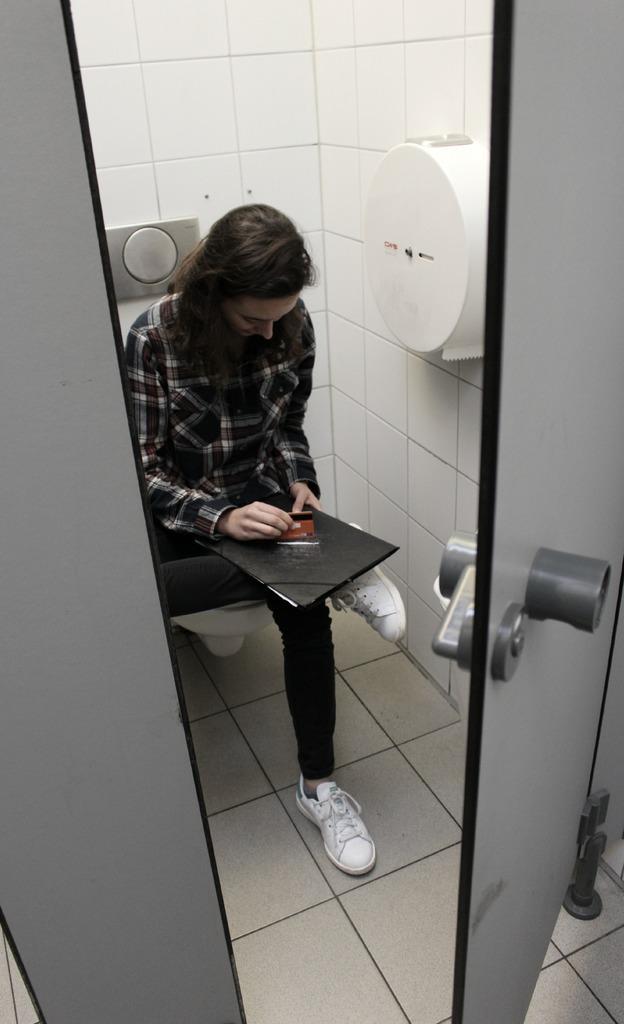Describe this image in one or two sentences. In this image, on the right side, we can see a door which is opened. In the middle of the image, we can see a person sitting on the toilet and keeping book on lap. On the right side of the image, we can see a tissue roll. On the left side, we can also see a gray color. In the background, we can see white color tiles. 